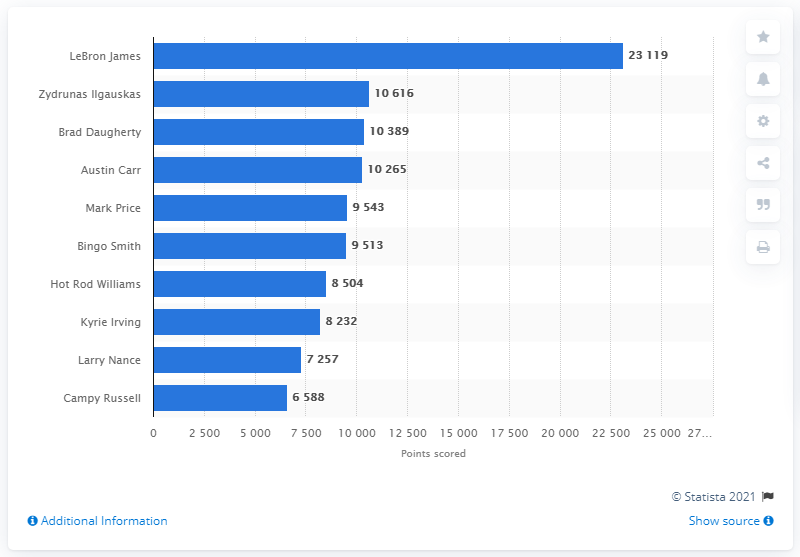List a handful of essential elements in this visual. LeBron James is the career points leader of the Cleveland Cavaliers. 